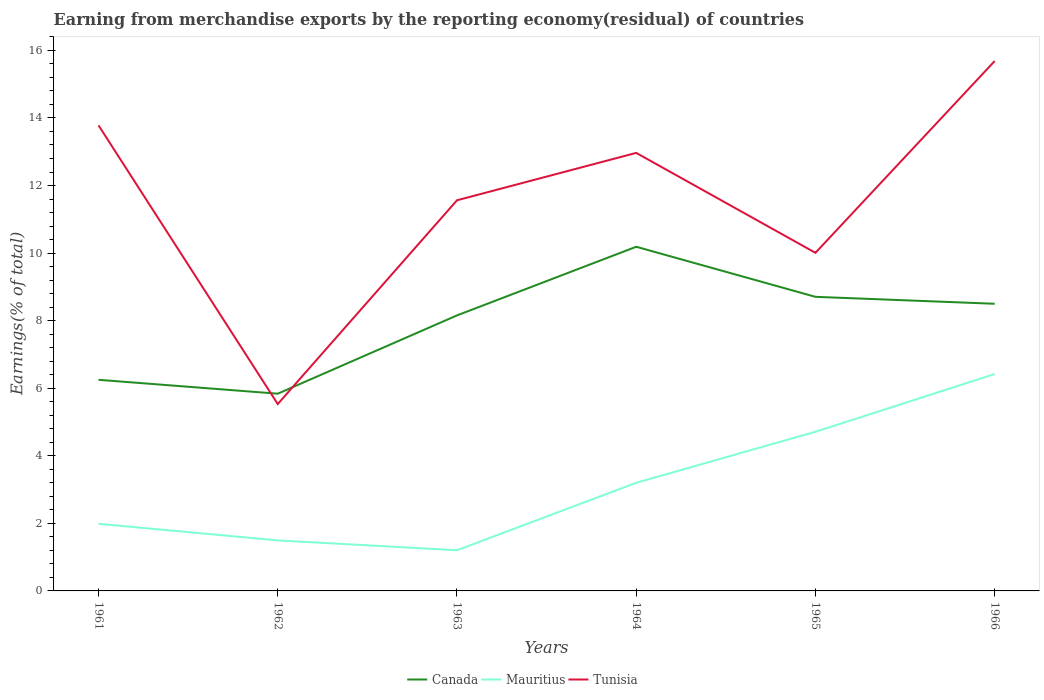Does the line corresponding to Tunisia intersect with the line corresponding to Mauritius?
Provide a short and direct response. No. Across all years, what is the maximum percentage of amount earned from merchandise exports in Canada?
Offer a very short reply. 5.84. In which year was the percentage of amount earned from merchandise exports in Canada maximum?
Offer a terse response. 1962. What is the total percentage of amount earned from merchandise exports in Mauritius in the graph?
Give a very brief answer. -1.71. What is the difference between the highest and the second highest percentage of amount earned from merchandise exports in Tunisia?
Provide a succinct answer. 10.15. How many years are there in the graph?
Your answer should be compact. 6. What is the difference between two consecutive major ticks on the Y-axis?
Your answer should be compact. 2. Are the values on the major ticks of Y-axis written in scientific E-notation?
Make the answer very short. No. Where does the legend appear in the graph?
Ensure brevity in your answer.  Bottom center. How many legend labels are there?
Your answer should be very brief. 3. How are the legend labels stacked?
Make the answer very short. Horizontal. What is the title of the graph?
Give a very brief answer. Earning from merchandise exports by the reporting economy(residual) of countries. What is the label or title of the Y-axis?
Keep it short and to the point. Earnings(% of total). What is the Earnings(% of total) of Canada in 1961?
Make the answer very short. 6.25. What is the Earnings(% of total) of Mauritius in 1961?
Provide a succinct answer. 1.99. What is the Earnings(% of total) of Tunisia in 1961?
Offer a very short reply. 13.78. What is the Earnings(% of total) in Canada in 1962?
Offer a terse response. 5.84. What is the Earnings(% of total) of Mauritius in 1962?
Ensure brevity in your answer.  1.5. What is the Earnings(% of total) of Tunisia in 1962?
Your answer should be compact. 5.53. What is the Earnings(% of total) of Canada in 1963?
Make the answer very short. 8.16. What is the Earnings(% of total) of Mauritius in 1963?
Keep it short and to the point. 1.2. What is the Earnings(% of total) of Tunisia in 1963?
Make the answer very short. 11.56. What is the Earnings(% of total) of Canada in 1964?
Make the answer very short. 10.19. What is the Earnings(% of total) of Mauritius in 1964?
Your answer should be compact. 3.2. What is the Earnings(% of total) of Tunisia in 1964?
Ensure brevity in your answer.  12.97. What is the Earnings(% of total) in Canada in 1965?
Offer a very short reply. 8.71. What is the Earnings(% of total) of Mauritius in 1965?
Your answer should be compact. 4.71. What is the Earnings(% of total) of Tunisia in 1965?
Provide a short and direct response. 10.01. What is the Earnings(% of total) of Canada in 1966?
Make the answer very short. 8.5. What is the Earnings(% of total) of Mauritius in 1966?
Your response must be concise. 6.42. What is the Earnings(% of total) in Tunisia in 1966?
Offer a very short reply. 15.68. Across all years, what is the maximum Earnings(% of total) of Canada?
Your answer should be very brief. 10.19. Across all years, what is the maximum Earnings(% of total) in Mauritius?
Give a very brief answer. 6.42. Across all years, what is the maximum Earnings(% of total) of Tunisia?
Offer a terse response. 15.68. Across all years, what is the minimum Earnings(% of total) of Canada?
Keep it short and to the point. 5.84. Across all years, what is the minimum Earnings(% of total) in Mauritius?
Your response must be concise. 1.2. Across all years, what is the minimum Earnings(% of total) in Tunisia?
Make the answer very short. 5.53. What is the total Earnings(% of total) in Canada in the graph?
Your answer should be compact. 47.63. What is the total Earnings(% of total) of Mauritius in the graph?
Provide a succinct answer. 19.02. What is the total Earnings(% of total) in Tunisia in the graph?
Your answer should be compact. 69.53. What is the difference between the Earnings(% of total) of Canada in 1961 and that in 1962?
Keep it short and to the point. 0.41. What is the difference between the Earnings(% of total) of Mauritius in 1961 and that in 1962?
Your response must be concise. 0.49. What is the difference between the Earnings(% of total) in Tunisia in 1961 and that in 1962?
Make the answer very short. 8.25. What is the difference between the Earnings(% of total) in Canada in 1961 and that in 1963?
Keep it short and to the point. -1.91. What is the difference between the Earnings(% of total) in Mauritius in 1961 and that in 1963?
Offer a terse response. 0.78. What is the difference between the Earnings(% of total) in Tunisia in 1961 and that in 1963?
Provide a succinct answer. 2.22. What is the difference between the Earnings(% of total) of Canada in 1961 and that in 1964?
Your answer should be very brief. -3.94. What is the difference between the Earnings(% of total) in Mauritius in 1961 and that in 1964?
Make the answer very short. -1.21. What is the difference between the Earnings(% of total) in Tunisia in 1961 and that in 1964?
Ensure brevity in your answer.  0.81. What is the difference between the Earnings(% of total) of Canada in 1961 and that in 1965?
Offer a very short reply. -2.46. What is the difference between the Earnings(% of total) of Mauritius in 1961 and that in 1965?
Offer a terse response. -2.72. What is the difference between the Earnings(% of total) of Tunisia in 1961 and that in 1965?
Your answer should be very brief. 3.77. What is the difference between the Earnings(% of total) of Canada in 1961 and that in 1966?
Your response must be concise. -2.25. What is the difference between the Earnings(% of total) of Mauritius in 1961 and that in 1966?
Give a very brief answer. -4.43. What is the difference between the Earnings(% of total) of Tunisia in 1961 and that in 1966?
Your response must be concise. -1.9. What is the difference between the Earnings(% of total) of Canada in 1962 and that in 1963?
Your answer should be very brief. -2.32. What is the difference between the Earnings(% of total) of Mauritius in 1962 and that in 1963?
Keep it short and to the point. 0.29. What is the difference between the Earnings(% of total) of Tunisia in 1962 and that in 1963?
Give a very brief answer. -6.03. What is the difference between the Earnings(% of total) in Canada in 1962 and that in 1964?
Give a very brief answer. -4.35. What is the difference between the Earnings(% of total) of Mauritius in 1962 and that in 1964?
Offer a terse response. -1.71. What is the difference between the Earnings(% of total) of Tunisia in 1962 and that in 1964?
Provide a short and direct response. -7.43. What is the difference between the Earnings(% of total) in Canada in 1962 and that in 1965?
Keep it short and to the point. -2.87. What is the difference between the Earnings(% of total) in Mauritius in 1962 and that in 1965?
Offer a very short reply. -3.22. What is the difference between the Earnings(% of total) of Tunisia in 1962 and that in 1965?
Your answer should be very brief. -4.48. What is the difference between the Earnings(% of total) in Canada in 1962 and that in 1966?
Keep it short and to the point. -2.66. What is the difference between the Earnings(% of total) of Mauritius in 1962 and that in 1966?
Provide a short and direct response. -4.93. What is the difference between the Earnings(% of total) in Tunisia in 1962 and that in 1966?
Your answer should be compact. -10.15. What is the difference between the Earnings(% of total) in Canada in 1963 and that in 1964?
Give a very brief answer. -2.03. What is the difference between the Earnings(% of total) in Mauritius in 1963 and that in 1964?
Give a very brief answer. -2. What is the difference between the Earnings(% of total) of Tunisia in 1963 and that in 1964?
Give a very brief answer. -1.4. What is the difference between the Earnings(% of total) in Canada in 1963 and that in 1965?
Your answer should be compact. -0.55. What is the difference between the Earnings(% of total) in Mauritius in 1963 and that in 1965?
Ensure brevity in your answer.  -3.51. What is the difference between the Earnings(% of total) in Tunisia in 1963 and that in 1965?
Give a very brief answer. 1.55. What is the difference between the Earnings(% of total) in Canada in 1963 and that in 1966?
Give a very brief answer. -0.34. What is the difference between the Earnings(% of total) in Mauritius in 1963 and that in 1966?
Your answer should be compact. -5.22. What is the difference between the Earnings(% of total) of Tunisia in 1963 and that in 1966?
Your answer should be compact. -4.12. What is the difference between the Earnings(% of total) of Canada in 1964 and that in 1965?
Your response must be concise. 1.48. What is the difference between the Earnings(% of total) in Mauritius in 1964 and that in 1965?
Give a very brief answer. -1.51. What is the difference between the Earnings(% of total) in Tunisia in 1964 and that in 1965?
Keep it short and to the point. 2.96. What is the difference between the Earnings(% of total) of Canada in 1964 and that in 1966?
Your answer should be compact. 1.69. What is the difference between the Earnings(% of total) in Mauritius in 1964 and that in 1966?
Your answer should be very brief. -3.22. What is the difference between the Earnings(% of total) of Tunisia in 1964 and that in 1966?
Keep it short and to the point. -2.72. What is the difference between the Earnings(% of total) in Canada in 1965 and that in 1966?
Your response must be concise. 0.21. What is the difference between the Earnings(% of total) in Mauritius in 1965 and that in 1966?
Keep it short and to the point. -1.71. What is the difference between the Earnings(% of total) of Tunisia in 1965 and that in 1966?
Your answer should be compact. -5.68. What is the difference between the Earnings(% of total) of Canada in 1961 and the Earnings(% of total) of Mauritius in 1962?
Provide a succinct answer. 4.75. What is the difference between the Earnings(% of total) of Canada in 1961 and the Earnings(% of total) of Tunisia in 1962?
Offer a very short reply. 0.72. What is the difference between the Earnings(% of total) in Mauritius in 1961 and the Earnings(% of total) in Tunisia in 1962?
Offer a very short reply. -3.54. What is the difference between the Earnings(% of total) of Canada in 1961 and the Earnings(% of total) of Mauritius in 1963?
Offer a terse response. 5.04. What is the difference between the Earnings(% of total) of Canada in 1961 and the Earnings(% of total) of Tunisia in 1963?
Provide a succinct answer. -5.31. What is the difference between the Earnings(% of total) of Mauritius in 1961 and the Earnings(% of total) of Tunisia in 1963?
Provide a short and direct response. -9.58. What is the difference between the Earnings(% of total) of Canada in 1961 and the Earnings(% of total) of Mauritius in 1964?
Provide a short and direct response. 3.05. What is the difference between the Earnings(% of total) of Canada in 1961 and the Earnings(% of total) of Tunisia in 1964?
Ensure brevity in your answer.  -6.72. What is the difference between the Earnings(% of total) in Mauritius in 1961 and the Earnings(% of total) in Tunisia in 1964?
Give a very brief answer. -10.98. What is the difference between the Earnings(% of total) of Canada in 1961 and the Earnings(% of total) of Mauritius in 1965?
Your answer should be compact. 1.54. What is the difference between the Earnings(% of total) in Canada in 1961 and the Earnings(% of total) in Tunisia in 1965?
Ensure brevity in your answer.  -3.76. What is the difference between the Earnings(% of total) in Mauritius in 1961 and the Earnings(% of total) in Tunisia in 1965?
Your answer should be very brief. -8.02. What is the difference between the Earnings(% of total) in Canada in 1961 and the Earnings(% of total) in Mauritius in 1966?
Your response must be concise. -0.17. What is the difference between the Earnings(% of total) in Canada in 1961 and the Earnings(% of total) in Tunisia in 1966?
Provide a short and direct response. -9.44. What is the difference between the Earnings(% of total) of Mauritius in 1961 and the Earnings(% of total) of Tunisia in 1966?
Your answer should be very brief. -13.7. What is the difference between the Earnings(% of total) in Canada in 1962 and the Earnings(% of total) in Mauritius in 1963?
Your response must be concise. 4.63. What is the difference between the Earnings(% of total) in Canada in 1962 and the Earnings(% of total) in Tunisia in 1963?
Keep it short and to the point. -5.73. What is the difference between the Earnings(% of total) in Mauritius in 1962 and the Earnings(% of total) in Tunisia in 1963?
Make the answer very short. -10.07. What is the difference between the Earnings(% of total) in Canada in 1962 and the Earnings(% of total) in Mauritius in 1964?
Your answer should be very brief. 2.64. What is the difference between the Earnings(% of total) of Canada in 1962 and the Earnings(% of total) of Tunisia in 1964?
Ensure brevity in your answer.  -7.13. What is the difference between the Earnings(% of total) in Mauritius in 1962 and the Earnings(% of total) in Tunisia in 1964?
Your answer should be very brief. -11.47. What is the difference between the Earnings(% of total) in Canada in 1962 and the Earnings(% of total) in Mauritius in 1965?
Provide a short and direct response. 1.13. What is the difference between the Earnings(% of total) of Canada in 1962 and the Earnings(% of total) of Tunisia in 1965?
Offer a terse response. -4.17. What is the difference between the Earnings(% of total) of Mauritius in 1962 and the Earnings(% of total) of Tunisia in 1965?
Make the answer very short. -8.51. What is the difference between the Earnings(% of total) of Canada in 1962 and the Earnings(% of total) of Mauritius in 1966?
Ensure brevity in your answer.  -0.58. What is the difference between the Earnings(% of total) in Canada in 1962 and the Earnings(% of total) in Tunisia in 1966?
Ensure brevity in your answer.  -9.85. What is the difference between the Earnings(% of total) in Mauritius in 1962 and the Earnings(% of total) in Tunisia in 1966?
Your answer should be very brief. -14.19. What is the difference between the Earnings(% of total) in Canada in 1963 and the Earnings(% of total) in Mauritius in 1964?
Offer a terse response. 4.95. What is the difference between the Earnings(% of total) in Canada in 1963 and the Earnings(% of total) in Tunisia in 1964?
Provide a succinct answer. -4.81. What is the difference between the Earnings(% of total) of Mauritius in 1963 and the Earnings(% of total) of Tunisia in 1964?
Keep it short and to the point. -11.76. What is the difference between the Earnings(% of total) in Canada in 1963 and the Earnings(% of total) in Mauritius in 1965?
Your response must be concise. 3.44. What is the difference between the Earnings(% of total) of Canada in 1963 and the Earnings(% of total) of Tunisia in 1965?
Make the answer very short. -1.85. What is the difference between the Earnings(% of total) of Mauritius in 1963 and the Earnings(% of total) of Tunisia in 1965?
Provide a short and direct response. -8.8. What is the difference between the Earnings(% of total) of Canada in 1963 and the Earnings(% of total) of Mauritius in 1966?
Your response must be concise. 1.73. What is the difference between the Earnings(% of total) of Canada in 1963 and the Earnings(% of total) of Tunisia in 1966?
Keep it short and to the point. -7.53. What is the difference between the Earnings(% of total) in Mauritius in 1963 and the Earnings(% of total) in Tunisia in 1966?
Make the answer very short. -14.48. What is the difference between the Earnings(% of total) in Canada in 1964 and the Earnings(% of total) in Mauritius in 1965?
Ensure brevity in your answer.  5.48. What is the difference between the Earnings(% of total) of Canada in 1964 and the Earnings(% of total) of Tunisia in 1965?
Offer a very short reply. 0.18. What is the difference between the Earnings(% of total) of Mauritius in 1964 and the Earnings(% of total) of Tunisia in 1965?
Provide a succinct answer. -6.81. What is the difference between the Earnings(% of total) in Canada in 1964 and the Earnings(% of total) in Mauritius in 1966?
Your answer should be compact. 3.77. What is the difference between the Earnings(% of total) of Canada in 1964 and the Earnings(% of total) of Tunisia in 1966?
Offer a terse response. -5.5. What is the difference between the Earnings(% of total) of Mauritius in 1964 and the Earnings(% of total) of Tunisia in 1966?
Your response must be concise. -12.48. What is the difference between the Earnings(% of total) of Canada in 1965 and the Earnings(% of total) of Mauritius in 1966?
Your answer should be compact. 2.28. What is the difference between the Earnings(% of total) in Canada in 1965 and the Earnings(% of total) in Tunisia in 1966?
Provide a short and direct response. -6.98. What is the difference between the Earnings(% of total) of Mauritius in 1965 and the Earnings(% of total) of Tunisia in 1966?
Give a very brief answer. -10.97. What is the average Earnings(% of total) in Canada per year?
Your answer should be compact. 7.94. What is the average Earnings(% of total) in Mauritius per year?
Provide a short and direct response. 3.17. What is the average Earnings(% of total) of Tunisia per year?
Ensure brevity in your answer.  11.59. In the year 1961, what is the difference between the Earnings(% of total) of Canada and Earnings(% of total) of Mauritius?
Make the answer very short. 4.26. In the year 1961, what is the difference between the Earnings(% of total) of Canada and Earnings(% of total) of Tunisia?
Give a very brief answer. -7.53. In the year 1961, what is the difference between the Earnings(% of total) in Mauritius and Earnings(% of total) in Tunisia?
Your response must be concise. -11.79. In the year 1962, what is the difference between the Earnings(% of total) of Canada and Earnings(% of total) of Mauritius?
Keep it short and to the point. 4.34. In the year 1962, what is the difference between the Earnings(% of total) in Canada and Earnings(% of total) in Tunisia?
Offer a terse response. 0.31. In the year 1962, what is the difference between the Earnings(% of total) of Mauritius and Earnings(% of total) of Tunisia?
Your response must be concise. -4.04. In the year 1963, what is the difference between the Earnings(% of total) of Canada and Earnings(% of total) of Mauritius?
Offer a terse response. 6.95. In the year 1963, what is the difference between the Earnings(% of total) in Canada and Earnings(% of total) in Tunisia?
Make the answer very short. -3.41. In the year 1963, what is the difference between the Earnings(% of total) in Mauritius and Earnings(% of total) in Tunisia?
Ensure brevity in your answer.  -10.36. In the year 1964, what is the difference between the Earnings(% of total) of Canada and Earnings(% of total) of Mauritius?
Make the answer very short. 6.99. In the year 1964, what is the difference between the Earnings(% of total) in Canada and Earnings(% of total) in Tunisia?
Your answer should be very brief. -2.78. In the year 1964, what is the difference between the Earnings(% of total) of Mauritius and Earnings(% of total) of Tunisia?
Ensure brevity in your answer.  -9.76. In the year 1965, what is the difference between the Earnings(% of total) of Canada and Earnings(% of total) of Mauritius?
Offer a very short reply. 3.99. In the year 1965, what is the difference between the Earnings(% of total) of Canada and Earnings(% of total) of Tunisia?
Keep it short and to the point. -1.3. In the year 1965, what is the difference between the Earnings(% of total) in Mauritius and Earnings(% of total) in Tunisia?
Give a very brief answer. -5.3. In the year 1966, what is the difference between the Earnings(% of total) in Canada and Earnings(% of total) in Mauritius?
Offer a terse response. 2.08. In the year 1966, what is the difference between the Earnings(% of total) of Canada and Earnings(% of total) of Tunisia?
Your answer should be very brief. -7.18. In the year 1966, what is the difference between the Earnings(% of total) of Mauritius and Earnings(% of total) of Tunisia?
Your response must be concise. -9.26. What is the ratio of the Earnings(% of total) in Canada in 1961 to that in 1962?
Ensure brevity in your answer.  1.07. What is the ratio of the Earnings(% of total) in Mauritius in 1961 to that in 1962?
Keep it short and to the point. 1.33. What is the ratio of the Earnings(% of total) in Tunisia in 1961 to that in 1962?
Ensure brevity in your answer.  2.49. What is the ratio of the Earnings(% of total) in Canada in 1961 to that in 1963?
Your answer should be very brief. 0.77. What is the ratio of the Earnings(% of total) of Mauritius in 1961 to that in 1963?
Your response must be concise. 1.65. What is the ratio of the Earnings(% of total) of Tunisia in 1961 to that in 1963?
Offer a very short reply. 1.19. What is the ratio of the Earnings(% of total) in Canada in 1961 to that in 1964?
Provide a short and direct response. 0.61. What is the ratio of the Earnings(% of total) of Mauritius in 1961 to that in 1964?
Provide a succinct answer. 0.62. What is the ratio of the Earnings(% of total) in Tunisia in 1961 to that in 1964?
Ensure brevity in your answer.  1.06. What is the ratio of the Earnings(% of total) of Canada in 1961 to that in 1965?
Offer a terse response. 0.72. What is the ratio of the Earnings(% of total) of Mauritius in 1961 to that in 1965?
Offer a very short reply. 0.42. What is the ratio of the Earnings(% of total) in Tunisia in 1961 to that in 1965?
Your answer should be compact. 1.38. What is the ratio of the Earnings(% of total) of Canada in 1961 to that in 1966?
Give a very brief answer. 0.74. What is the ratio of the Earnings(% of total) in Mauritius in 1961 to that in 1966?
Your answer should be compact. 0.31. What is the ratio of the Earnings(% of total) in Tunisia in 1961 to that in 1966?
Provide a succinct answer. 0.88. What is the ratio of the Earnings(% of total) in Canada in 1962 to that in 1963?
Ensure brevity in your answer.  0.72. What is the ratio of the Earnings(% of total) of Mauritius in 1962 to that in 1963?
Provide a short and direct response. 1.24. What is the ratio of the Earnings(% of total) in Tunisia in 1962 to that in 1963?
Make the answer very short. 0.48. What is the ratio of the Earnings(% of total) in Canada in 1962 to that in 1964?
Keep it short and to the point. 0.57. What is the ratio of the Earnings(% of total) in Mauritius in 1962 to that in 1964?
Offer a terse response. 0.47. What is the ratio of the Earnings(% of total) of Tunisia in 1962 to that in 1964?
Offer a terse response. 0.43. What is the ratio of the Earnings(% of total) in Canada in 1962 to that in 1965?
Give a very brief answer. 0.67. What is the ratio of the Earnings(% of total) in Mauritius in 1962 to that in 1965?
Give a very brief answer. 0.32. What is the ratio of the Earnings(% of total) in Tunisia in 1962 to that in 1965?
Ensure brevity in your answer.  0.55. What is the ratio of the Earnings(% of total) in Canada in 1962 to that in 1966?
Your answer should be very brief. 0.69. What is the ratio of the Earnings(% of total) of Mauritius in 1962 to that in 1966?
Your answer should be compact. 0.23. What is the ratio of the Earnings(% of total) of Tunisia in 1962 to that in 1966?
Offer a very short reply. 0.35. What is the ratio of the Earnings(% of total) of Canada in 1963 to that in 1964?
Keep it short and to the point. 0.8. What is the ratio of the Earnings(% of total) in Mauritius in 1963 to that in 1964?
Offer a terse response. 0.38. What is the ratio of the Earnings(% of total) of Tunisia in 1963 to that in 1964?
Provide a succinct answer. 0.89. What is the ratio of the Earnings(% of total) of Canada in 1963 to that in 1965?
Provide a succinct answer. 0.94. What is the ratio of the Earnings(% of total) of Mauritius in 1963 to that in 1965?
Give a very brief answer. 0.26. What is the ratio of the Earnings(% of total) in Tunisia in 1963 to that in 1965?
Your answer should be compact. 1.16. What is the ratio of the Earnings(% of total) in Canada in 1963 to that in 1966?
Give a very brief answer. 0.96. What is the ratio of the Earnings(% of total) of Mauritius in 1963 to that in 1966?
Offer a very short reply. 0.19. What is the ratio of the Earnings(% of total) of Tunisia in 1963 to that in 1966?
Your response must be concise. 0.74. What is the ratio of the Earnings(% of total) in Canada in 1964 to that in 1965?
Keep it short and to the point. 1.17. What is the ratio of the Earnings(% of total) of Mauritius in 1964 to that in 1965?
Offer a very short reply. 0.68. What is the ratio of the Earnings(% of total) of Tunisia in 1964 to that in 1965?
Your answer should be compact. 1.3. What is the ratio of the Earnings(% of total) of Canada in 1964 to that in 1966?
Ensure brevity in your answer.  1.2. What is the ratio of the Earnings(% of total) of Mauritius in 1964 to that in 1966?
Offer a terse response. 0.5. What is the ratio of the Earnings(% of total) in Tunisia in 1964 to that in 1966?
Make the answer very short. 0.83. What is the ratio of the Earnings(% of total) of Canada in 1965 to that in 1966?
Give a very brief answer. 1.02. What is the ratio of the Earnings(% of total) in Mauritius in 1965 to that in 1966?
Ensure brevity in your answer.  0.73. What is the ratio of the Earnings(% of total) of Tunisia in 1965 to that in 1966?
Ensure brevity in your answer.  0.64. What is the difference between the highest and the second highest Earnings(% of total) in Canada?
Your answer should be very brief. 1.48. What is the difference between the highest and the second highest Earnings(% of total) of Mauritius?
Offer a very short reply. 1.71. What is the difference between the highest and the second highest Earnings(% of total) in Tunisia?
Ensure brevity in your answer.  1.9. What is the difference between the highest and the lowest Earnings(% of total) of Canada?
Provide a succinct answer. 4.35. What is the difference between the highest and the lowest Earnings(% of total) in Mauritius?
Provide a short and direct response. 5.22. What is the difference between the highest and the lowest Earnings(% of total) of Tunisia?
Provide a short and direct response. 10.15. 